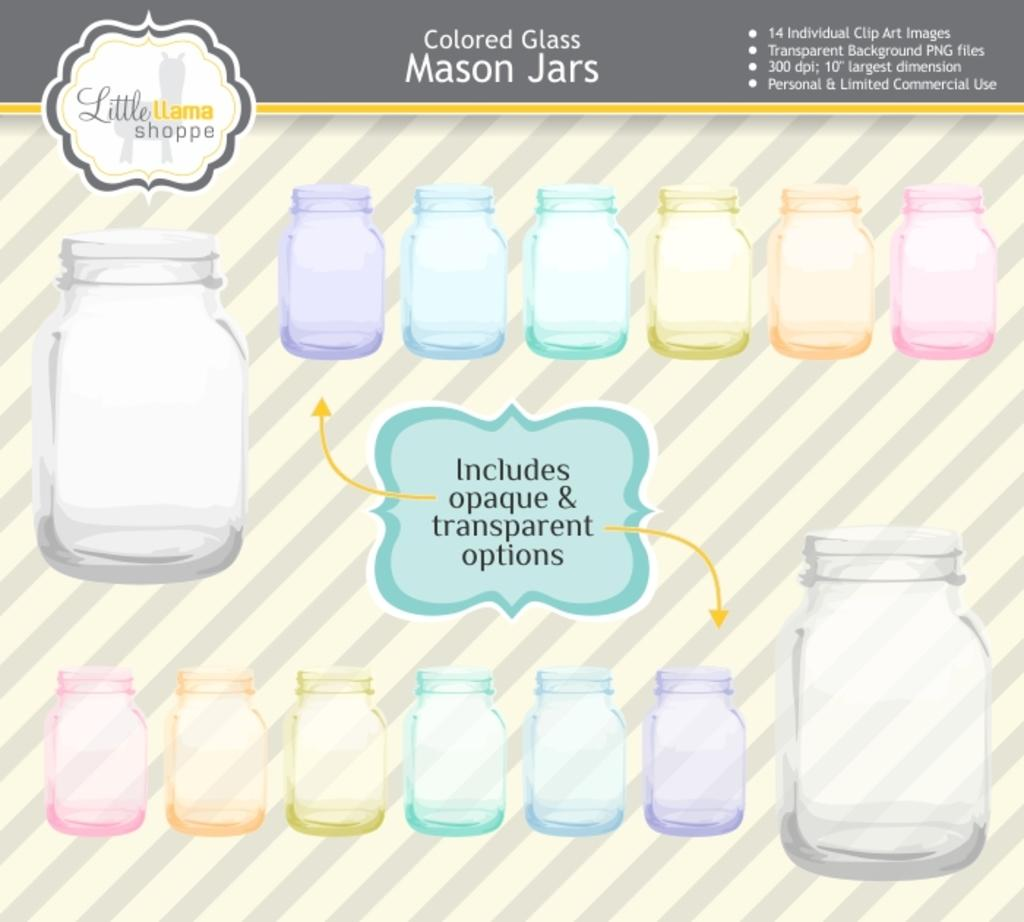<image>
Render a clear and concise summary of the photo. Description of colored glass mason jars with label in the middle that is green. 